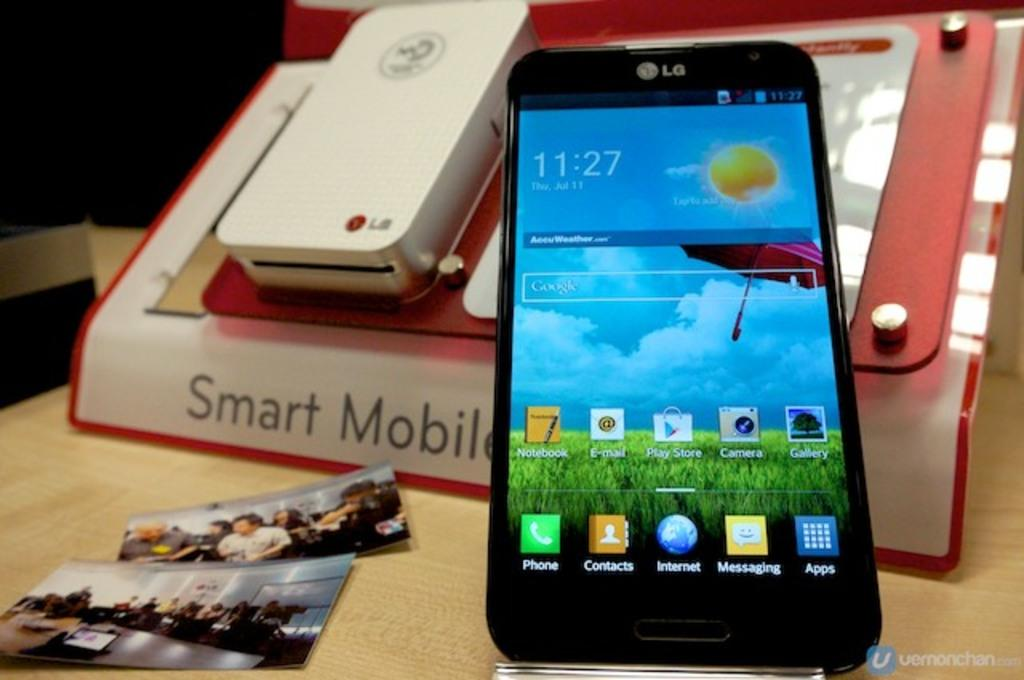Provide a one-sentence caption for the provided image. An LG cell phone with the home screen displayed laying on a notebook that says Smart Mobile on it. 